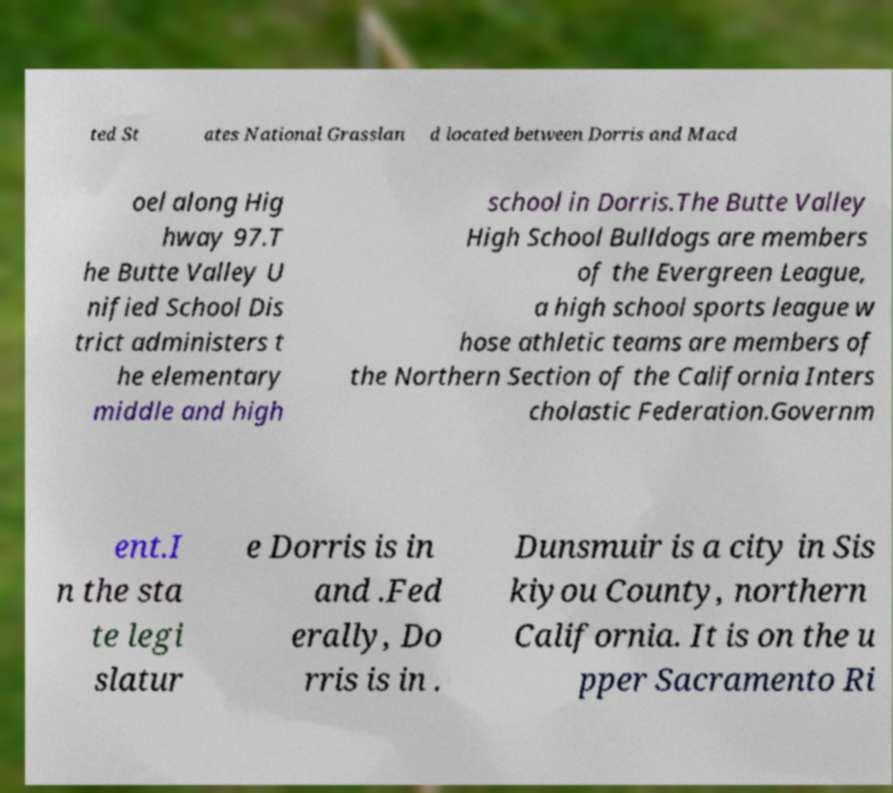Could you assist in decoding the text presented in this image and type it out clearly? ted St ates National Grasslan d located between Dorris and Macd oel along Hig hway 97.T he Butte Valley U nified School Dis trict administers t he elementary middle and high school in Dorris.The Butte Valley High School Bulldogs are members of the Evergreen League, a high school sports league w hose athletic teams are members of the Northern Section of the California Inters cholastic Federation.Governm ent.I n the sta te legi slatur e Dorris is in and .Fed erally, Do rris is in . Dunsmuir is a city in Sis kiyou County, northern California. It is on the u pper Sacramento Ri 